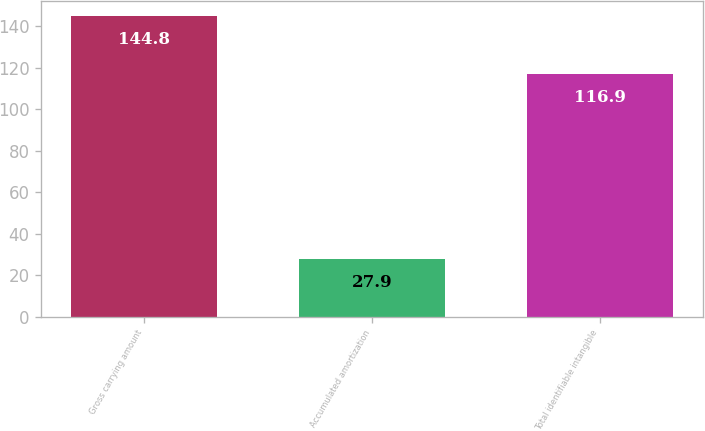Convert chart. <chart><loc_0><loc_0><loc_500><loc_500><bar_chart><fcel>Gross carrying amount<fcel>Accumulated amortization<fcel>Total identifiable intangible<nl><fcel>144.8<fcel>27.9<fcel>116.9<nl></chart> 